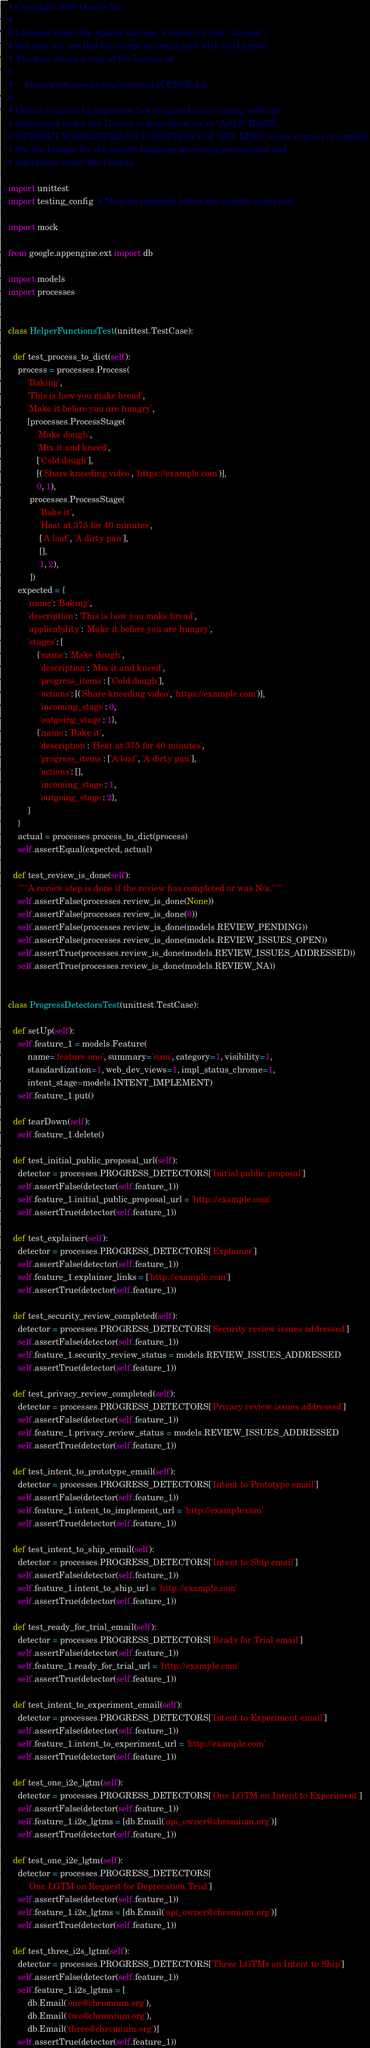<code> <loc_0><loc_0><loc_500><loc_500><_Python_># Copyright 2020 Google Inc.
#
# Licensed under the Apache License, Version 2.0 (the "License")
# you may not use this file except in compliance with the License.
# You may obtain a copy of the License at
#
#     http://www.apache.org/licenses/LICENSE-2.0
#
# Unless required by applicable law or agreed to in writing, software
# distributed under the License is distributed on an "AS IS" BASIS,
# WITHOUT WARRANTIES OR CONDITIONS OF ANY KIND, either express or implied.
# See the License for the specific language governing permissions and
# limitations under the License.

import unittest
import testing_config  # Must be imported before the module under test.

import mock

from google.appengine.ext import db

import models
import processes


class HelperFunctionsTest(unittest.TestCase):

  def test_process_to_dict(self):
    process = processes.Process(
        'Baking',
        'This is how you make bread',
        'Make it before you are hungry',
        [processes.ProcessStage(
            'Make dough',
            'Mix it and kneed',
            ['Cold dough'],
            [('Share kneeding video', 'https://example.com')],
            0, 1),
         processes.ProcessStage(
             'Bake it',
             'Heat at 375 for 40 minutes',
             ['A loaf', 'A dirty pan'],
             [],
             1, 2),
         ])
    expected = {
        'name': 'Baking',
        'description': 'This is how you make bread',
        'applicability': 'Make it before you are hungry',
        'stages': [
            {'name': 'Make dough',
             'description': 'Mix it and kneed',
             'progress_items': ['Cold dough'],
             'actions': [('Share kneeding video', 'https://example.com')],
             'incoming_stage': 0,
             'outgoing_stage': 1},
            {'name': 'Bake it',
             'description': 'Heat at 375 for 40 minutes',
             'progress_items': ['A loaf', 'A dirty pan'],
             'actions': [],
             'incoming_stage': 1,
             'outgoing_stage': 2},
        ]
    }
    actual = processes.process_to_dict(process)
    self.assertEqual(expected, actual)

  def test_review_is_done(self):
    """A review step is done if the review has completed or was N/a."""
    self.assertFalse(processes.review_is_done(None))
    self.assertFalse(processes.review_is_done(0))
    self.assertFalse(processes.review_is_done(models.REVIEW_PENDING))
    self.assertFalse(processes.review_is_done(models.REVIEW_ISSUES_OPEN))
    self.assertTrue(processes.review_is_done(models.REVIEW_ISSUES_ADDRESSED))
    self.assertTrue(processes.review_is_done(models.REVIEW_NA))


class ProgressDetectorsTest(unittest.TestCase):

  def setUp(self):
    self.feature_1 = models.Feature(
        name='feature one', summary='sum', category=1, visibility=1,
        standardization=1, web_dev_views=1, impl_status_chrome=1,
        intent_stage=models.INTENT_IMPLEMENT)
    self.feature_1.put()

  def tearDown(self):
    self.feature_1.delete()

  def test_initial_public_proposal_url(self):
    detector = processes.PROGRESS_DETECTORS['Initial public proposal']
    self.assertFalse(detector(self.feature_1))
    self.feature_1.initial_public_proposal_url = 'http://example.com'
    self.assertTrue(detector(self.feature_1))

  def test_explainer(self):
    detector = processes.PROGRESS_DETECTORS['Explainer']
    self.assertFalse(detector(self.feature_1))
    self.feature_1.explainer_links = ['http://example.com']
    self.assertTrue(detector(self.feature_1))

  def test_security_review_completed(self):
    detector = processes.PROGRESS_DETECTORS['Security review issues addressed']
    self.assertFalse(detector(self.feature_1))
    self.feature_1.security_review_status = models.REVIEW_ISSUES_ADDRESSED
    self.assertTrue(detector(self.feature_1))

  def test_privacy_review_completed(self):
    detector = processes.PROGRESS_DETECTORS['Privacy review issues addressed']
    self.assertFalse(detector(self.feature_1))
    self.feature_1.privacy_review_status = models.REVIEW_ISSUES_ADDRESSED
    self.assertTrue(detector(self.feature_1))

  def test_intent_to_prototype_email(self):
    detector = processes.PROGRESS_DETECTORS['Intent to Prototype email']
    self.assertFalse(detector(self.feature_1))
    self.feature_1.intent_to_implement_url = 'http://example.com'
    self.assertTrue(detector(self.feature_1))

  def test_intent_to_ship_email(self):
    detector = processes.PROGRESS_DETECTORS['Intent to Ship email']
    self.assertFalse(detector(self.feature_1))
    self.feature_1.intent_to_ship_url = 'http://example.com'
    self.assertTrue(detector(self.feature_1))

  def test_ready_for_trial_email(self):
    detector = processes.PROGRESS_DETECTORS['Ready for Trial email']
    self.assertFalse(detector(self.feature_1))
    self.feature_1.ready_for_trial_url = 'http://example.com'
    self.assertTrue(detector(self.feature_1))

  def test_intent_to_experiment_email(self):
    detector = processes.PROGRESS_DETECTORS['Intent to Experiment email']
    self.assertFalse(detector(self.feature_1))
    self.feature_1.intent_to_experiment_url = 'http://example.com'
    self.assertTrue(detector(self.feature_1))

  def test_one_i2e_lgtm(self):
    detector = processes.PROGRESS_DETECTORS['One LGTM on Intent to Experiment']
    self.assertFalse(detector(self.feature_1))
    self.feature_1.i2e_lgtms = [db.Email('api_owner@chromium.org')]
    self.assertTrue(detector(self.feature_1))

  def test_one_i2e_lgtm(self):
    detector = processes.PROGRESS_DETECTORS[
        'One LGTM on Request for Deprecation Trial']
    self.assertFalse(detector(self.feature_1))
    self.feature_1.i2e_lgtms = [db.Email('api_owner@chromium.org')]
    self.assertTrue(detector(self.feature_1))

  def test_three_i2s_lgtm(self):
    detector = processes.PROGRESS_DETECTORS['Three LGTMs on Intent to Ship']
    self.assertFalse(detector(self.feature_1))
    self.feature_1.i2s_lgtms = [
        db.Email('one@chromium.org'),
        db.Email('two@chromium.org'),
        db.Email('three@chromium.org')]
    self.assertTrue(detector(self.feature_1))
</code> 